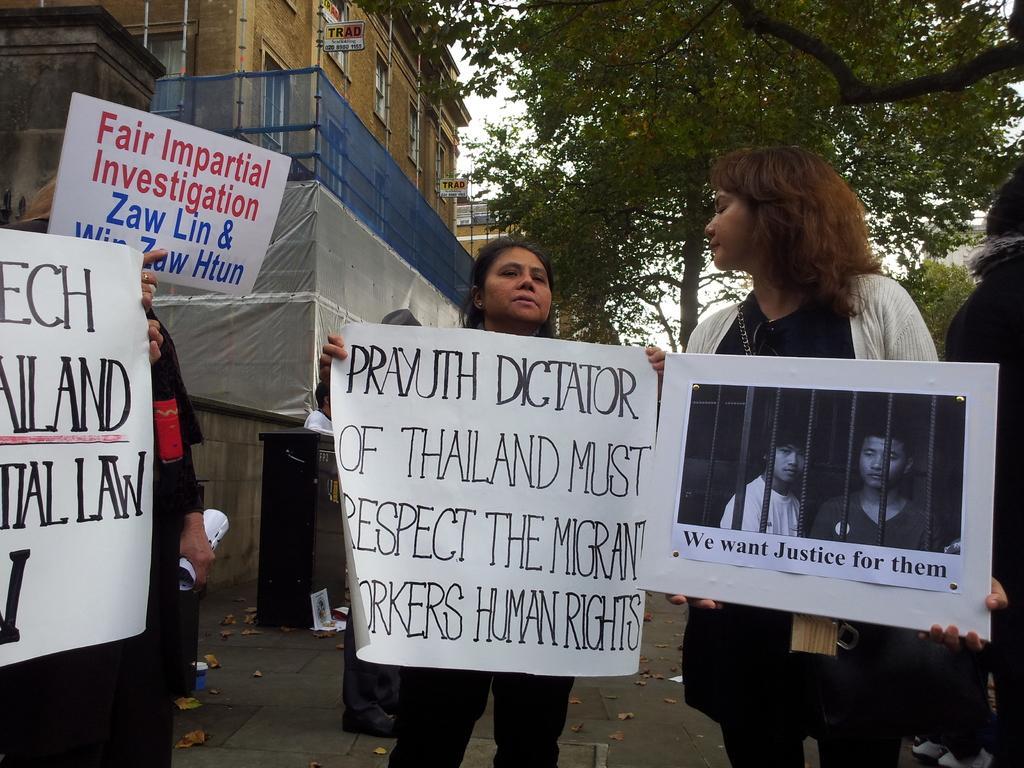Describe this image in one or two sentences. In this image we can see people standing, holding papers with some text and images. In the background of the image there are buildings and trees. At the bottom of the image there is road. 